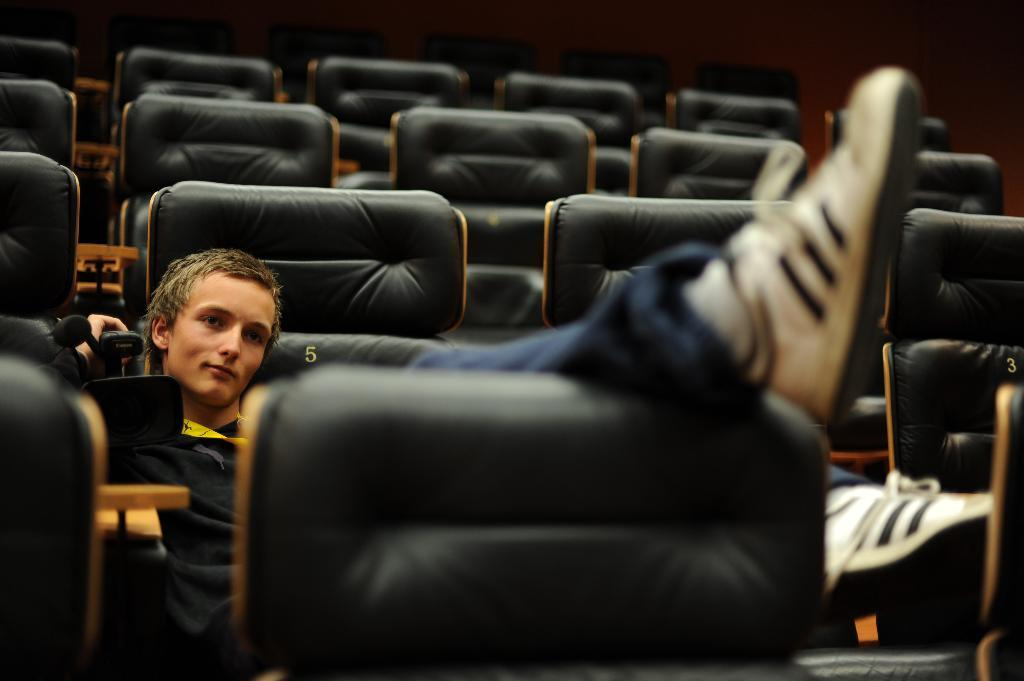How many chairs are in the room in the image? There are many chairs in the room in the image. What is the person in the image doing? The person is sitting on a chair and has their leg on another chair. What is the person holding in the image? The person is holding a camera. How many ladybugs can be seen on the person's shirt in the image? There are no ladybugs visible on the person's shirt in the image. 